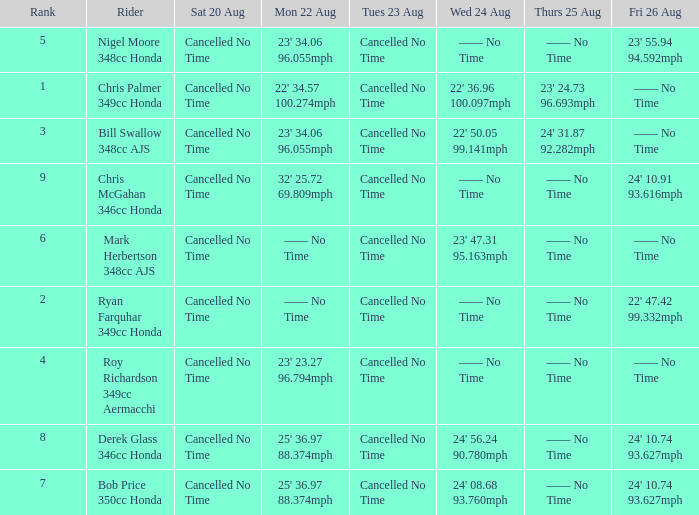What is every entry on Monday August 22 when the entry for Wednesday August 24 is 22' 50.05 99.141mph? 23' 34.06 96.055mph. 